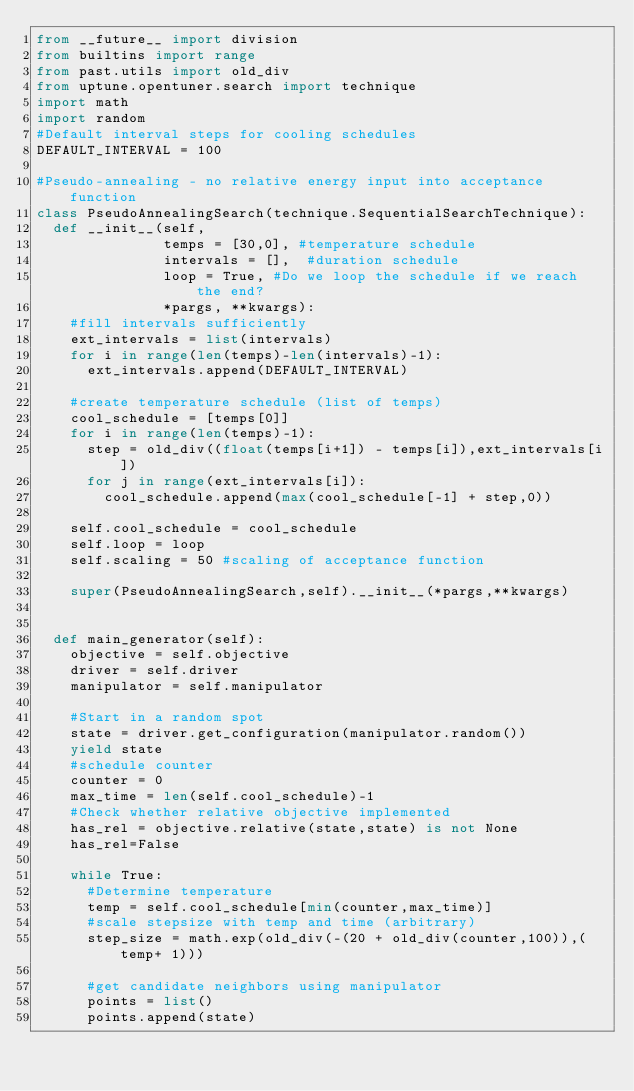Convert code to text. <code><loc_0><loc_0><loc_500><loc_500><_Python_>from __future__ import division
from builtins import range
from past.utils import old_div
from uptune.opentuner.search import technique
import math
import random
#Default interval steps for cooling schedules
DEFAULT_INTERVAL = 100

#Pseudo-annealing - no relative energy input into acceptance function
class PseudoAnnealingSearch(technique.SequentialSearchTechnique):
  def __init__(self,
               temps = [30,0], #temperature schedule
               intervals = [],  #duration schedule
          		 loop = True, #Do we loop the schedule if we reach the end?
               *pargs, **kwargs):
    #fill intervals sufficiently
    ext_intervals = list(intervals)
    for i in range(len(temps)-len(intervals)-1):
      ext_intervals.append(DEFAULT_INTERVAL)
            
    #create temperature schedule (list of temps)
    cool_schedule = [temps[0]]
    for i in range(len(temps)-1):
      step = old_div((float(temps[i+1]) - temps[i]),ext_intervals[i])
      for j in range(ext_intervals[i]):
        cool_schedule.append(max(cool_schedule[-1] + step,0))
      
    self.cool_schedule = cool_schedule
    self.loop = loop
    self.scaling = 50 #scaling of acceptance function
      
    super(PseudoAnnealingSearch,self).__init__(*pargs,**kwargs)


  def main_generator(self):
    objective = self.objective
    driver = self.driver
    manipulator = self.manipulator

    #Start in a random spot
    state = driver.get_configuration(manipulator.random())
    yield state
    #schedule counter
    counter = 0
    max_time = len(self.cool_schedule)-1
    #Check whether relative objective implemented
    has_rel = objective.relative(state,state) is not None
    has_rel=False
              
    while True:
      #Determine temperature
      temp = self.cool_schedule[min(counter,max_time)]
      #scale stepsize with temp and time (arbitrary)
      step_size = math.exp(old_div(-(20 + old_div(counter,100)),(temp+ 1))) 
          
      #get candidate neighbors using manipulator
      points = list()
      points.append(state)</code> 